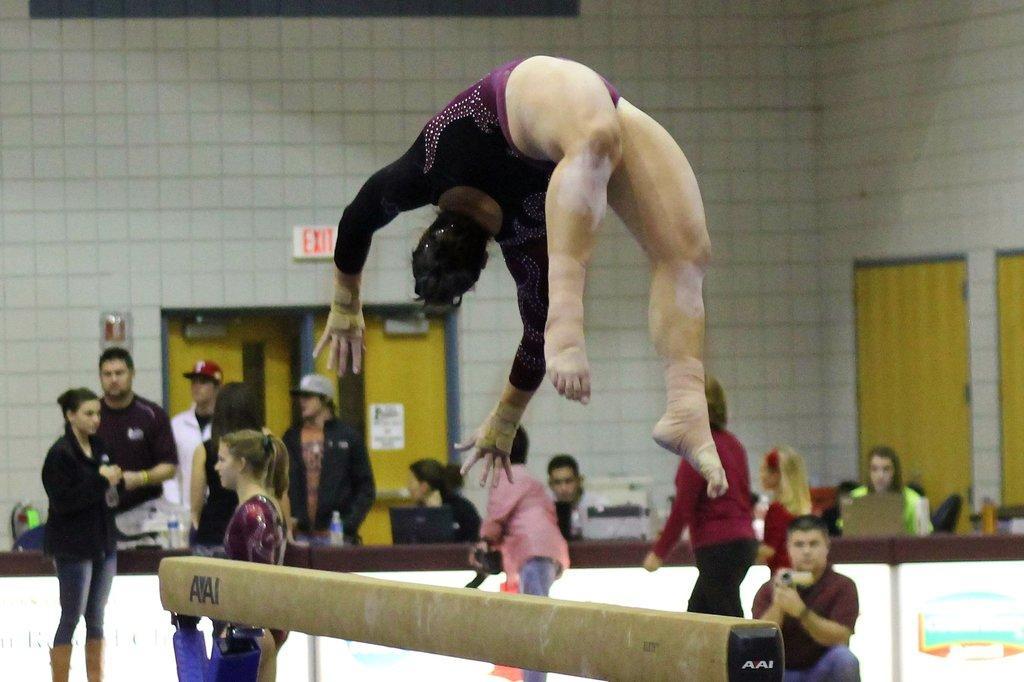Describe this image in one or two sentences. In this image we can see a few people, among them some are standing and some people are sitting, one person is doing gymnastics, there are laptops and water bottles, in the background we can see the wall with boards and doors. 